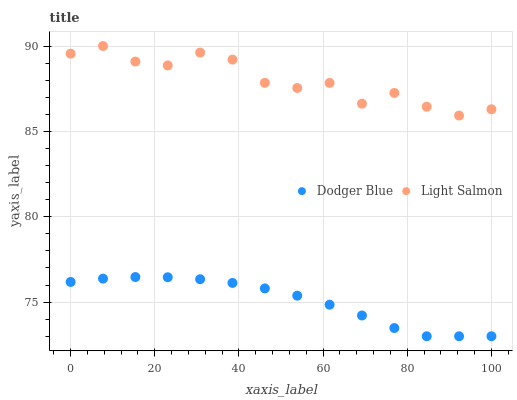Does Dodger Blue have the minimum area under the curve?
Answer yes or no. Yes. Does Light Salmon have the maximum area under the curve?
Answer yes or no. Yes. Does Dodger Blue have the maximum area under the curve?
Answer yes or no. No. Is Dodger Blue the smoothest?
Answer yes or no. Yes. Is Light Salmon the roughest?
Answer yes or no. Yes. Is Dodger Blue the roughest?
Answer yes or no. No. Does Dodger Blue have the lowest value?
Answer yes or no. Yes. Does Light Salmon have the highest value?
Answer yes or no. Yes. Does Dodger Blue have the highest value?
Answer yes or no. No. Is Dodger Blue less than Light Salmon?
Answer yes or no. Yes. Is Light Salmon greater than Dodger Blue?
Answer yes or no. Yes. Does Dodger Blue intersect Light Salmon?
Answer yes or no. No. 